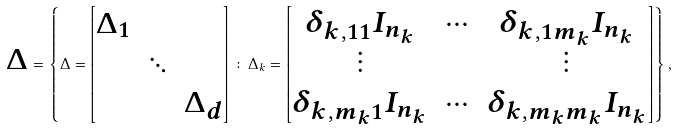Convert formula to latex. <formula><loc_0><loc_0><loc_500><loc_500>\boldsymbol \Delta = \left \{ \Delta = \begin{bmatrix} \Delta _ { 1 } & & \\ & \ddots & \\ & & \Delta _ { d } \end{bmatrix} \colon \Delta _ { k } = \begin{bmatrix} \delta _ { k , 1 1 } I _ { n _ { k } } & \cdots & \delta _ { k , 1 m _ { k } } I _ { n _ { k } } \\ \vdots & & \vdots \\ \delta _ { k , m _ { k } 1 } I _ { n _ { k } } & \cdots & \delta _ { k , m _ { k } m _ { k } } I _ { n _ { k } } \end{bmatrix} \right \} ,</formula> 